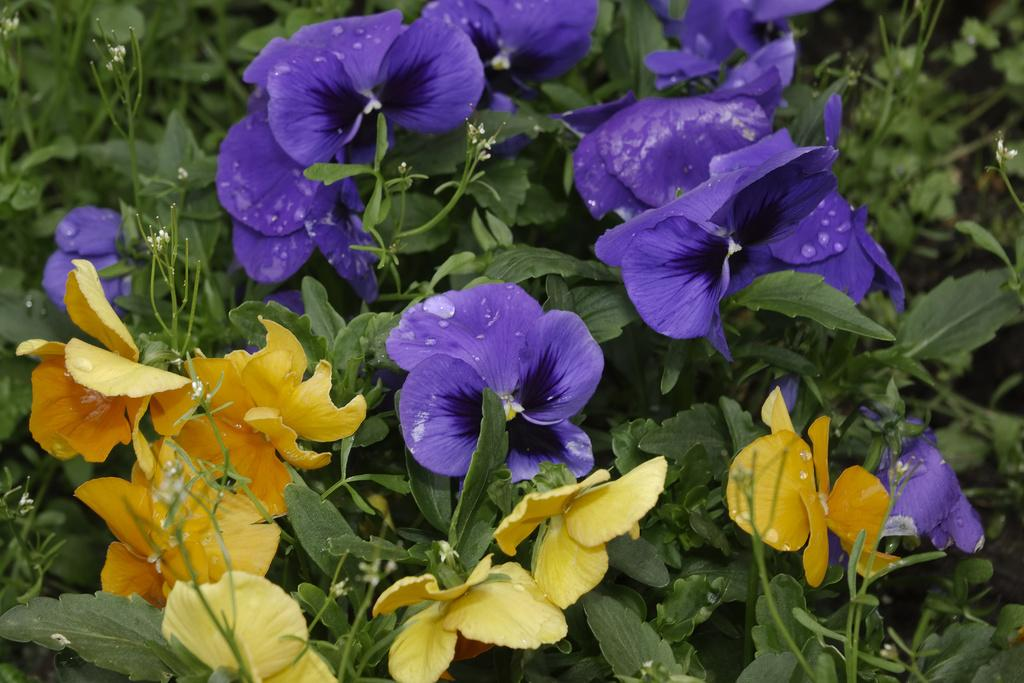What type of vegetation is present in the image? There are trees in the image. What color are the flowers on the trees? The trees have blue flowers and yellow flowers. How many feet does the aunt have in the image? There is no mention of an aunt or feet in the image, as it only features trees with blue and yellow flowers. 